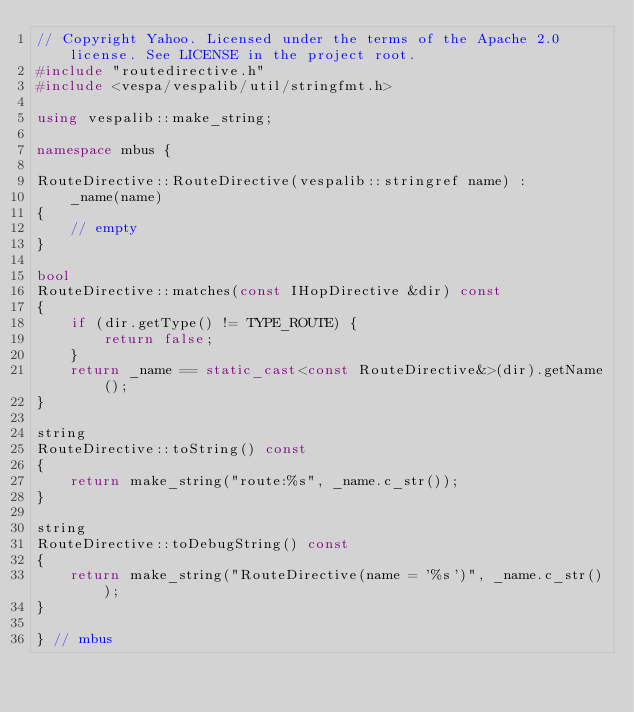Convert code to text. <code><loc_0><loc_0><loc_500><loc_500><_C++_>// Copyright Yahoo. Licensed under the terms of the Apache 2.0 license. See LICENSE in the project root.
#include "routedirective.h"
#include <vespa/vespalib/util/stringfmt.h>

using vespalib::make_string;

namespace mbus {

RouteDirective::RouteDirective(vespalib::stringref name) :
    _name(name)
{
    // empty
}

bool
RouteDirective::matches(const IHopDirective &dir) const
{
    if (dir.getType() != TYPE_ROUTE) {
        return false;
    }
    return _name == static_cast<const RouteDirective&>(dir).getName();
}

string
RouteDirective::toString() const
{
    return make_string("route:%s", _name.c_str());
}

string
RouteDirective::toDebugString() const
{
    return make_string("RouteDirective(name = '%s')", _name.c_str());
}

} // mbus
</code> 